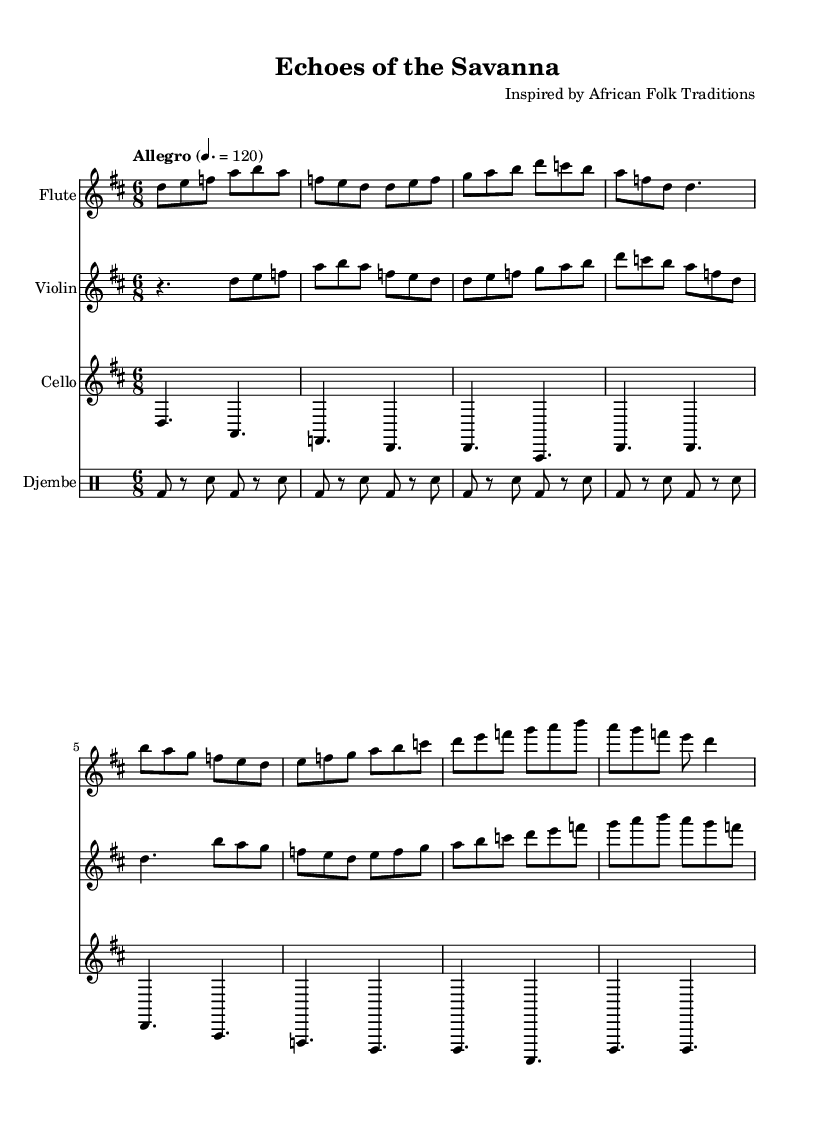What is the key signature of this music? The key signature is D major, which has two sharps (F# and C#). You can determine this by looking at the key signature indicated at the beginning of the score.
Answer: D major What is the time signature of this music? The time signature is 6/8, which indicates that there are six eighth notes in each measure. You can find this in the time signature marking at the beginning of the score.
Answer: 6/8 What is the tempo marking for this piece? The tempo marking is "Allegro," which suggests a fast and lively tempo. This is indicated at the beginning of the score along with the metronome marking of 120 beats per minute.
Answer: Allegro How many instruments are written in this score? There are four instruments in this score: flute, violin, cello, and djembe. You can count the number of staves at the beginning of the score to get this information.
Answer: Four What rhythmic pattern does the djembe play? The djembe plays a pattern with alternating bass and snare beats, typical in African music. This can be observed in the drum notation where the bass drum (bd) and snare (sn) appear in a repeating pattern.
Answer: Alternating bass and snare Which instrument has the highest pitch range in this piece? The flute has the highest pitch range. This can be confirmed by comparing the written notes of each instrument, where the flute part appears at higher pitches than the violin and cello.
Answer: Flute What is the main melodic theme of the flute in the first measure? The main melodic theme of the flute in the first measure consists of the notes D, E, and F, played in sequence. This can be seen clearly in the first measure of the flute staff.
Answer: D, E, F 